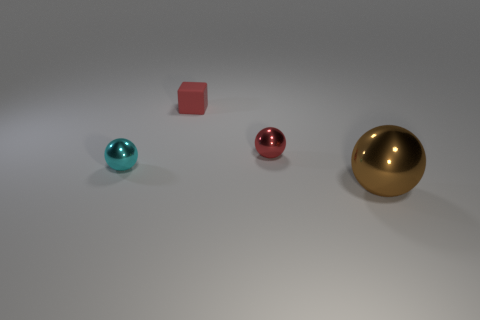Add 2 red spheres. How many objects exist? 6 Subtract all cubes. How many objects are left? 3 Add 4 large purple shiny cubes. How many large purple shiny cubes exist? 4 Subtract 0 green cylinders. How many objects are left? 4 Subtract all large brown metal things. Subtract all red matte objects. How many objects are left? 2 Add 1 red spheres. How many red spheres are left? 2 